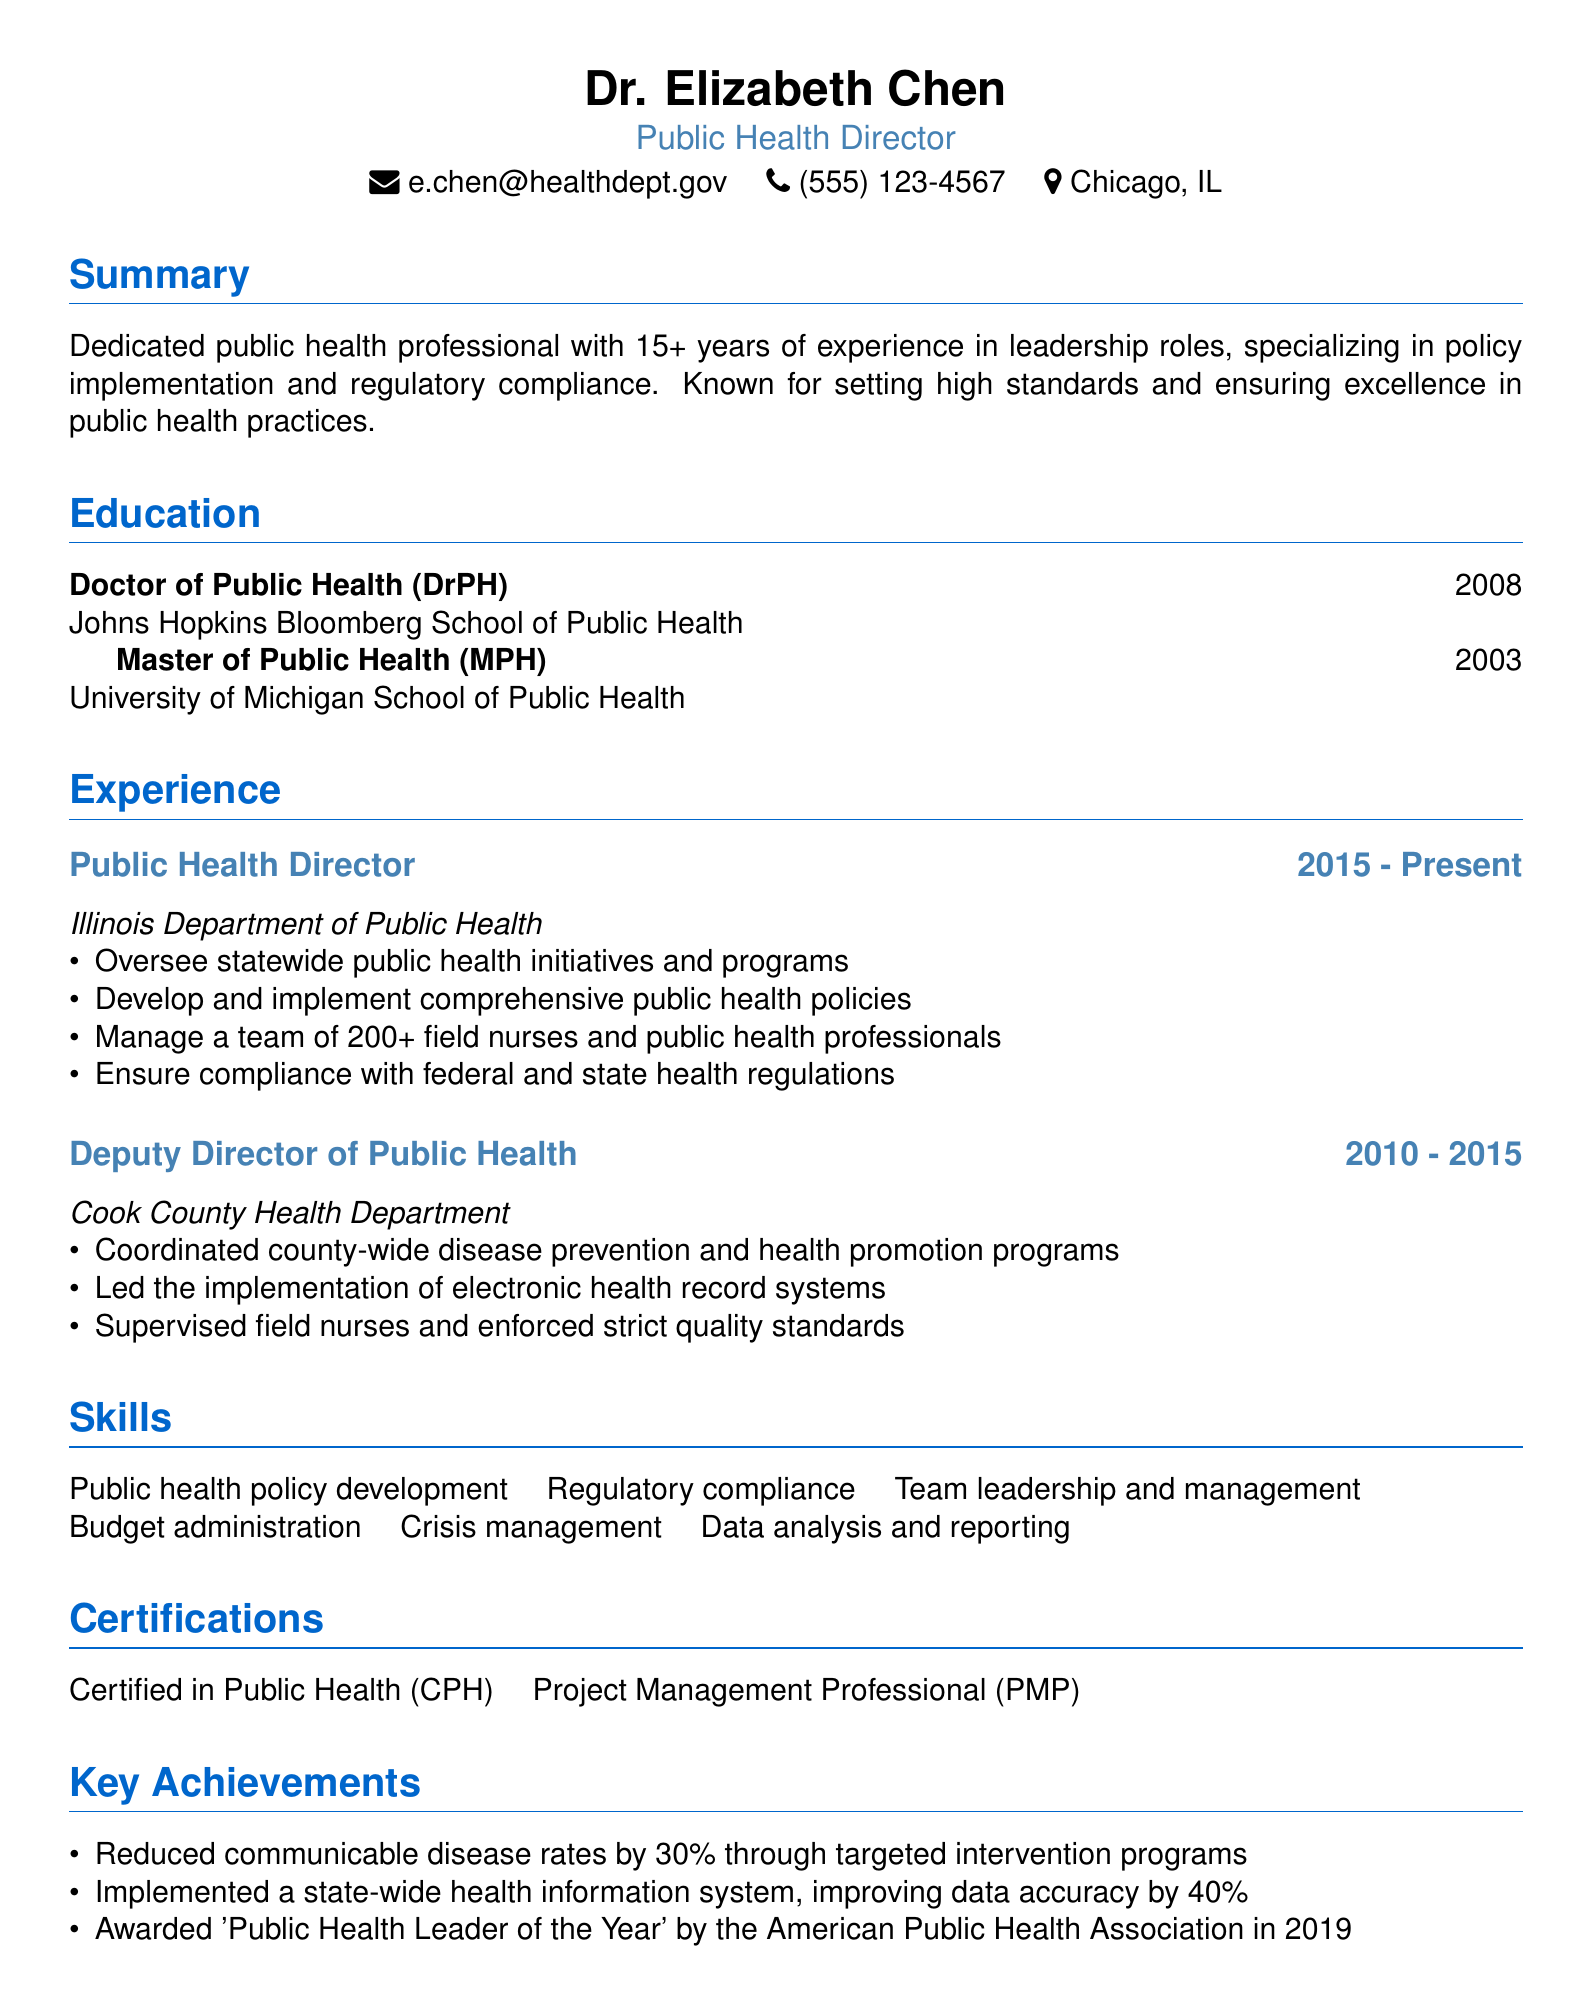what is the name of the public health director? The document states the name of the public health director is Dr. Elizabeth Chen.
Answer: Dr. Elizabeth Chen what is the most recent position held by Dr. Elizabeth Chen? The document lists her current position as Public Health Director at the Illinois Department of Public Health.
Answer: Public Health Director how many years of experience does Dr. Elizabeth Chen have in public health? The summary in the document mentions she has over 15 years of experience in public health.
Answer: 15+ what was Dr. Chen's degree and institution of higher education for her Doctorate? The education section states she earned a Doctor of Public Health from Johns Hopkins Bloomberg School of Public Health.
Answer: Doctor of Public Health from Johns Hopkins Bloomberg School of Public Health which significant award did Dr. Elizabeth Chen receive in 2019? The achievements section mentions she was awarded 'Public Health Leader of the Year' by the American Public Health Association in 2019.
Answer: Public Health Leader of the Year what significant reduction in communicable disease rates did Dr. Chen achieve? The document indicates she reduced communicable disease rates by 30% through targeted intervention programs.
Answer: 30% how many field nurses does Dr. Elizabeth Chen manage? The document states she manages a team of 200+ field nurses and public health professionals.
Answer: 200+ which professional credentials does Dr. Chen hold? The certifications section lists her as Certified in Public Health and a Project Management Professional.
Answer: Certified in Public Health, Project Management Professional 